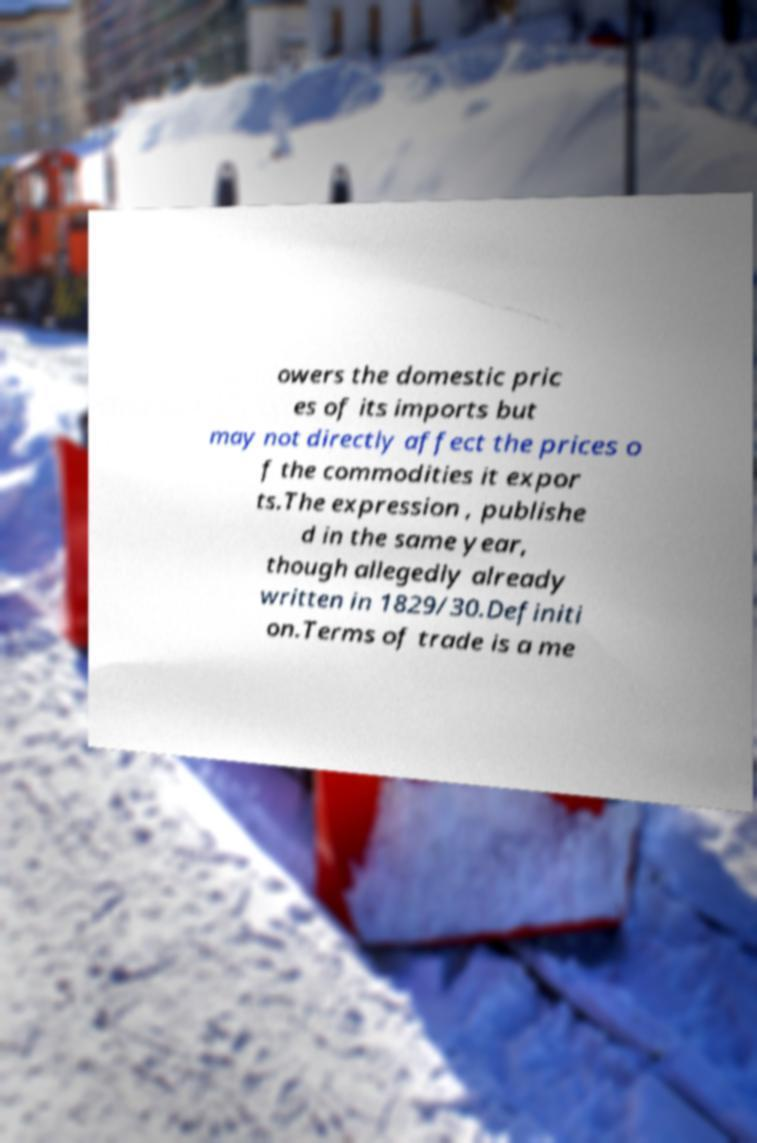Please identify and transcribe the text found in this image. owers the domestic pric es of its imports but may not directly affect the prices o f the commodities it expor ts.The expression , publishe d in the same year, though allegedly already written in 1829/30.Definiti on.Terms of trade is a me 